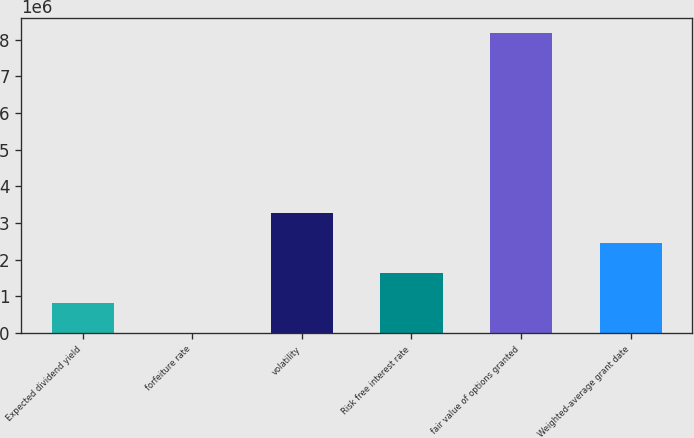Convert chart to OTSL. <chart><loc_0><loc_0><loc_500><loc_500><bar_chart><fcel>Expected dividend yield<fcel>forfeiture rate<fcel>volatility<fcel>Risk free interest rate<fcel>fair value of options granted<fcel>Weighted-average grant date<nl><fcel>817802<fcel>2.46<fcel>3.2712e+06<fcel>1.6356e+06<fcel>8.178e+06<fcel>2.4534e+06<nl></chart> 